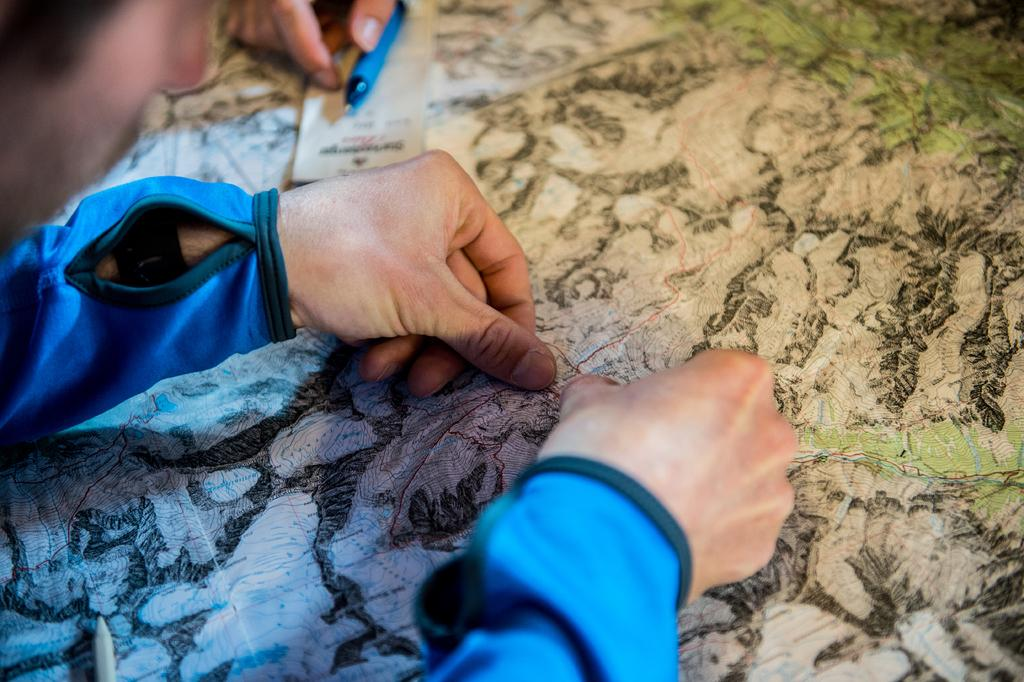What is the main subject of the image? There is a person in the image. What is the person doing with their thumb nails? The person's thumb nails are on a map. Can you describe the person's hand in the image? There is a hand in the image. What writing instruments are visible in the image? There is a pen and a pencil in the image. What is the person likely using to write or draw on? There is paper in the image. How many spiders are crawling on the person's hand in the image? There are no spiders present in the image. What is the person's reaction to the surprise in the image? There is no surprise depicted in the image. 